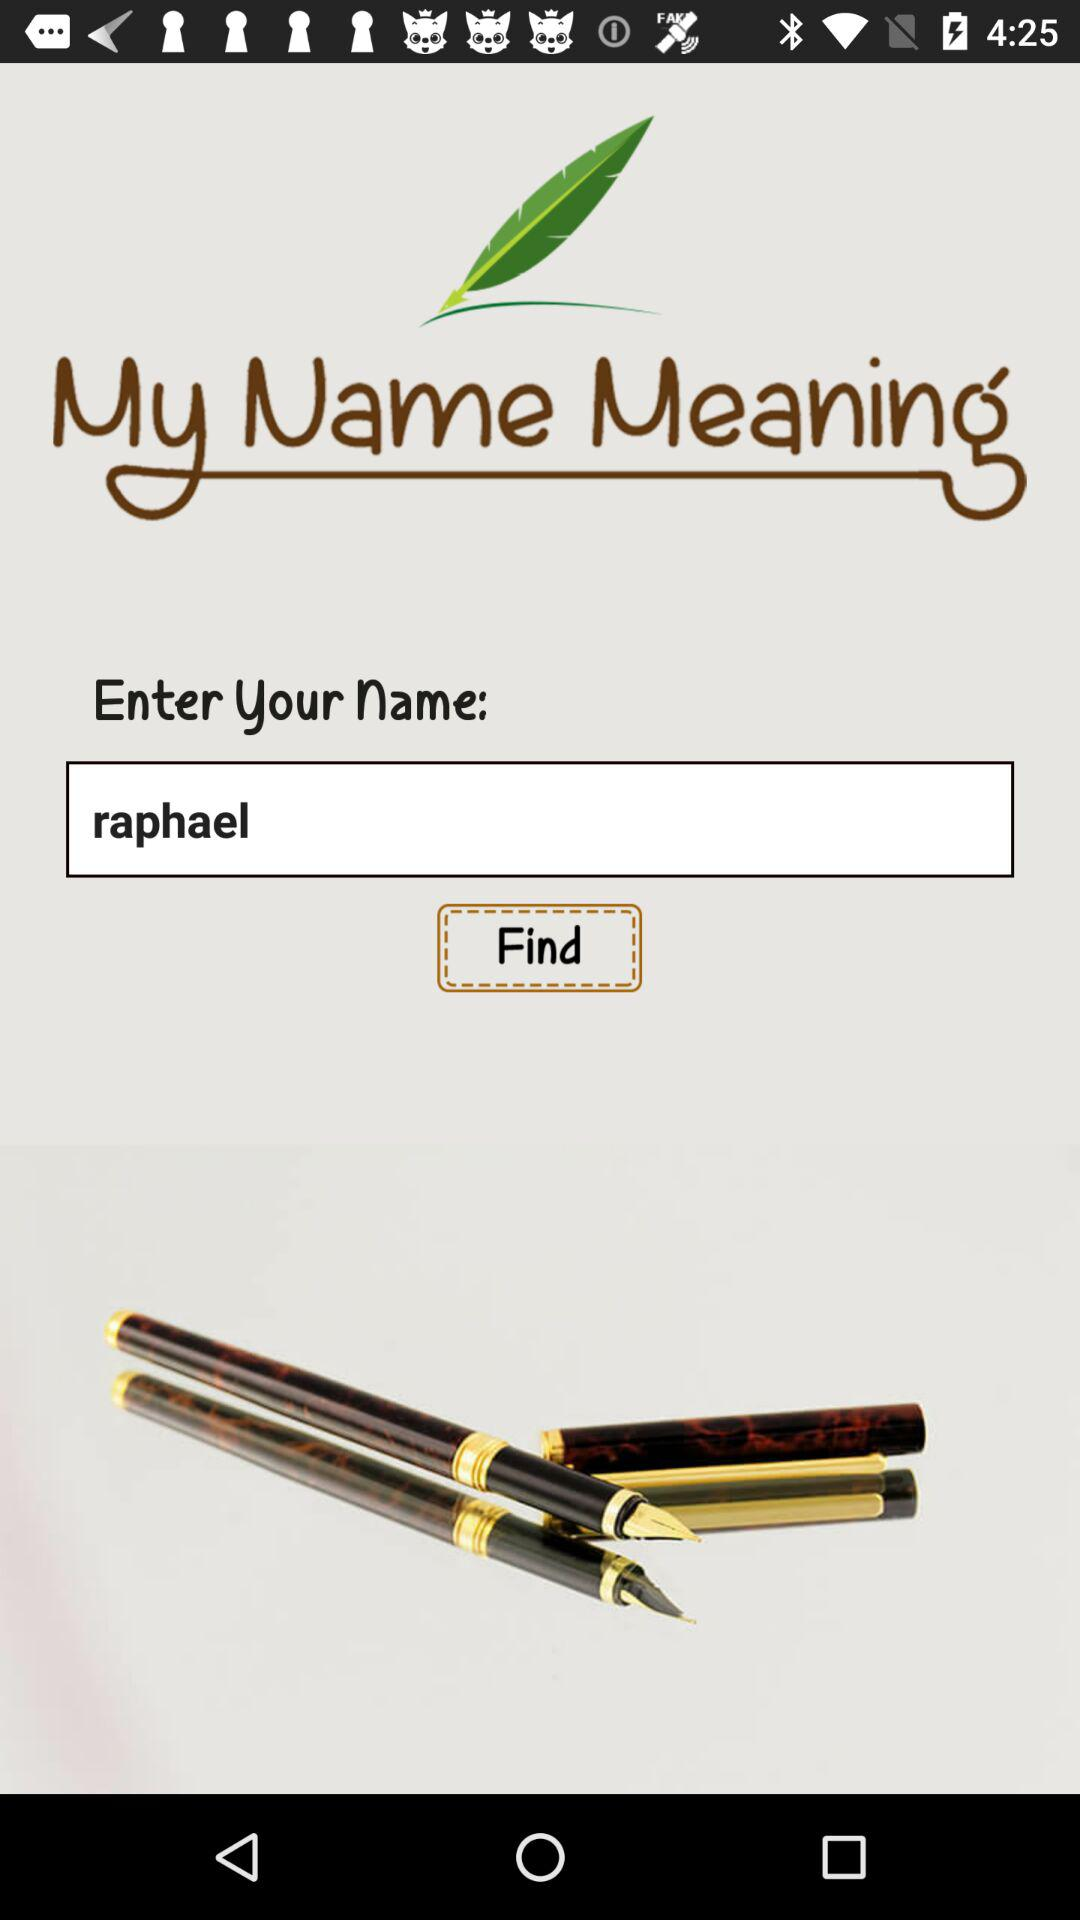What is the name of the application? The name of the application is "My Name Meaning". 